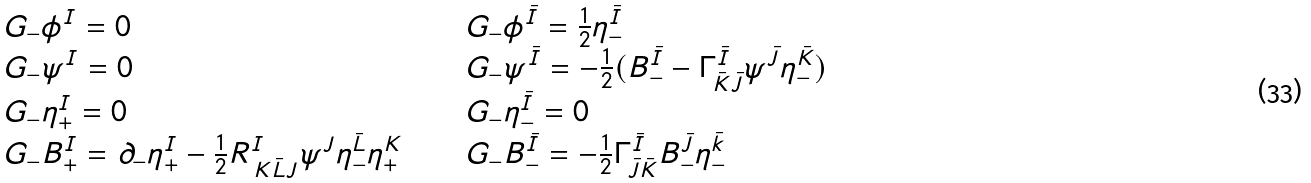<formula> <loc_0><loc_0><loc_500><loc_500>\begin{array} { l l l } G _ { - } \phi ^ { I } = 0 & \quad & G _ { - } \phi ^ { \bar { I } } = \frac { 1 } { 2 } \eta ^ { \bar { I } } _ { - } \\ G _ { - } \psi ^ { I } = 0 & \quad & G _ { - } \psi ^ { \bar { I } } = - \frac { 1 } { 2 } ( B ^ { \bar { I } } _ { - } - \Gamma ^ { \bar { I } } _ { \bar { K } \bar { J } } \psi ^ { \bar { J } } \eta ^ { \bar { K } } _ { - } ) \\ G _ { - } \eta ^ { I } _ { + } = 0 & \quad & G _ { - } \eta ^ { \bar { I } } _ { - } = 0 \\ G _ { - } B ^ { I } _ { + } = \partial _ { - } \eta ^ { I } _ { + } - \frac { 1 } { 2 } R ^ { I } _ { \, K \bar { L } J } \psi ^ { J } \eta ^ { \bar { L } } _ { - } \eta ^ { K } _ { + } & \quad & G _ { - } B ^ { \bar { I } } _ { - } = - \frac { 1 } { 2 } \Gamma ^ { \bar { I } } _ { \bar { J } \bar { K } } B ^ { \bar { J } } _ { - } \eta ^ { \bar { k } } _ { - } \\ \end{array}</formula> 